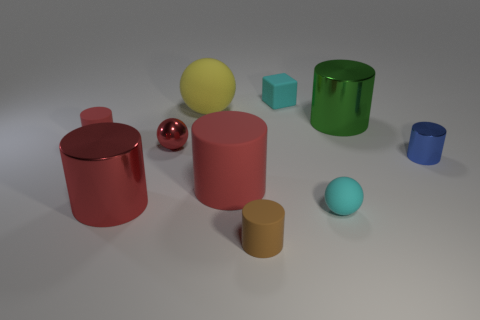Does the small rubber thing in front of the tiny rubber sphere have the same color as the small sphere that is on the right side of the brown cylinder? After examining the objects in the image, I note that the small rubber object in front of the tiny sphere is pink, while the small sphere to the right of the brown cylinder is a cyan-like color. They are distinctly different, so they do not share the same color. 